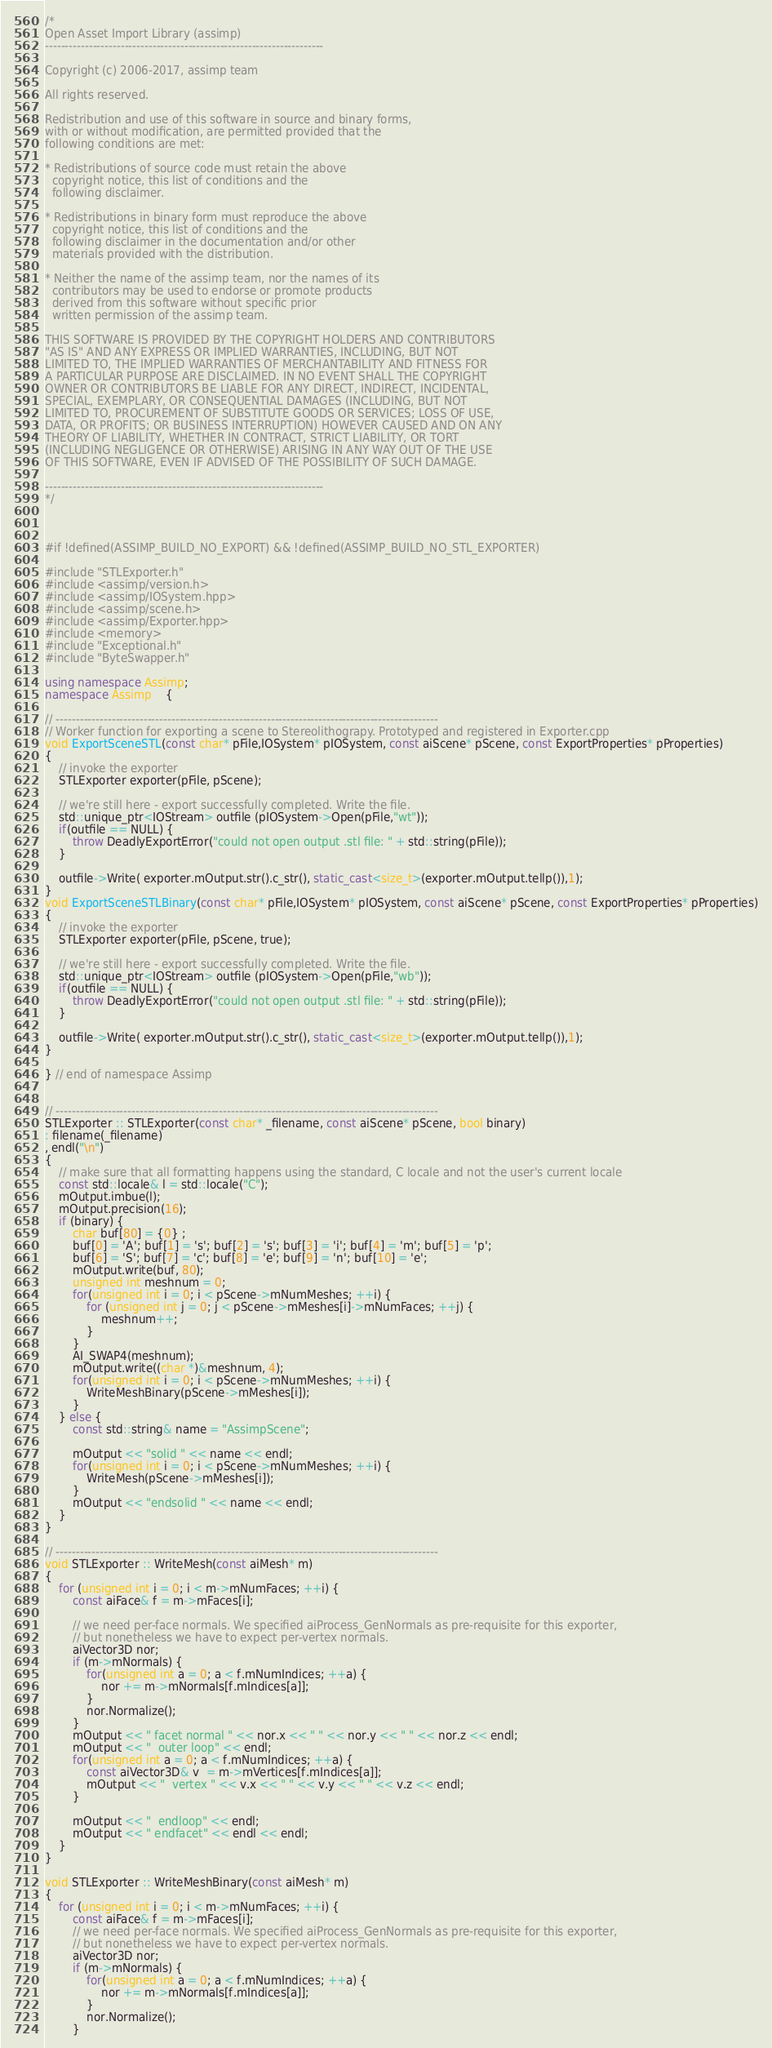<code> <loc_0><loc_0><loc_500><loc_500><_C++_>/*
Open Asset Import Library (assimp)
----------------------------------------------------------------------

Copyright (c) 2006-2017, assimp team

All rights reserved.

Redistribution and use of this software in source and binary forms,
with or without modification, are permitted provided that the
following conditions are met:

* Redistributions of source code must retain the above
  copyright notice, this list of conditions and the
  following disclaimer.

* Redistributions in binary form must reproduce the above
  copyright notice, this list of conditions and the
  following disclaimer in the documentation and/or other
  materials provided with the distribution.

* Neither the name of the assimp team, nor the names of its
  contributors may be used to endorse or promote products
  derived from this software without specific prior
  written permission of the assimp team.

THIS SOFTWARE IS PROVIDED BY THE COPYRIGHT HOLDERS AND CONTRIBUTORS
"AS IS" AND ANY EXPRESS OR IMPLIED WARRANTIES, INCLUDING, BUT NOT
LIMITED TO, THE IMPLIED WARRANTIES OF MERCHANTABILITY AND FITNESS FOR
A PARTICULAR PURPOSE ARE DISCLAIMED. IN NO EVENT SHALL THE COPYRIGHT
OWNER OR CONTRIBUTORS BE LIABLE FOR ANY DIRECT, INDIRECT, INCIDENTAL,
SPECIAL, EXEMPLARY, OR CONSEQUENTIAL DAMAGES (INCLUDING, BUT NOT
LIMITED TO, PROCUREMENT OF SUBSTITUTE GOODS OR SERVICES; LOSS OF USE,
DATA, OR PROFITS; OR BUSINESS INTERRUPTION) HOWEVER CAUSED AND ON ANY
THEORY OF LIABILITY, WHETHER IN CONTRACT, STRICT LIABILITY, OR TORT
(INCLUDING NEGLIGENCE OR OTHERWISE) ARISING IN ANY WAY OUT OF THE USE
OF THIS SOFTWARE, EVEN IF ADVISED OF THE POSSIBILITY OF SUCH DAMAGE.

----------------------------------------------------------------------
*/



#if !defined(ASSIMP_BUILD_NO_EXPORT) && !defined(ASSIMP_BUILD_NO_STL_EXPORTER)

#include "STLExporter.h"
#include <assimp/version.h>
#include <assimp/IOSystem.hpp>
#include <assimp/scene.h>
#include <assimp/Exporter.hpp>
#include <memory>
#include "Exceptional.h"
#include "ByteSwapper.h"

using namespace Assimp;
namespace Assimp    {

// ------------------------------------------------------------------------------------------------
// Worker function for exporting a scene to Stereolithograpy. Prototyped and registered in Exporter.cpp
void ExportSceneSTL(const char* pFile,IOSystem* pIOSystem, const aiScene* pScene, const ExportProperties* pProperties)
{
    // invoke the exporter
    STLExporter exporter(pFile, pScene);

    // we're still here - export successfully completed. Write the file.
    std::unique_ptr<IOStream> outfile (pIOSystem->Open(pFile,"wt"));
    if(outfile == NULL) {
        throw DeadlyExportError("could not open output .stl file: " + std::string(pFile));
    }

    outfile->Write( exporter.mOutput.str().c_str(), static_cast<size_t>(exporter.mOutput.tellp()),1);
}
void ExportSceneSTLBinary(const char* pFile,IOSystem* pIOSystem, const aiScene* pScene, const ExportProperties* pProperties)
{
    // invoke the exporter
    STLExporter exporter(pFile, pScene, true);

    // we're still here - export successfully completed. Write the file.
    std::unique_ptr<IOStream> outfile (pIOSystem->Open(pFile,"wb"));
    if(outfile == NULL) {
        throw DeadlyExportError("could not open output .stl file: " + std::string(pFile));
    }

    outfile->Write( exporter.mOutput.str().c_str(), static_cast<size_t>(exporter.mOutput.tellp()),1);
}

} // end of namespace Assimp


// ------------------------------------------------------------------------------------------------
STLExporter :: STLExporter(const char* _filename, const aiScene* pScene, bool binary)
: filename(_filename)
, endl("\n")
{
    // make sure that all formatting happens using the standard, C locale and not the user's current locale
    const std::locale& l = std::locale("C");
    mOutput.imbue(l);
    mOutput.precision(16);
    if (binary) {
        char buf[80] = {0} ;
        buf[0] = 'A'; buf[1] = 's'; buf[2] = 's'; buf[3] = 'i'; buf[4] = 'm'; buf[5] = 'p';
        buf[6] = 'S'; buf[7] = 'c'; buf[8] = 'e'; buf[9] = 'n'; buf[10] = 'e';
        mOutput.write(buf, 80);
        unsigned int meshnum = 0;
        for(unsigned int i = 0; i < pScene->mNumMeshes; ++i) {
            for (unsigned int j = 0; j < pScene->mMeshes[i]->mNumFaces; ++j) {
                meshnum++;
            }
        }
        AI_SWAP4(meshnum);
        mOutput.write((char *)&meshnum, 4);
        for(unsigned int i = 0; i < pScene->mNumMeshes; ++i) {
            WriteMeshBinary(pScene->mMeshes[i]);
        }
    } else {
        const std::string& name = "AssimpScene";

        mOutput << "solid " << name << endl;
        for(unsigned int i = 0; i < pScene->mNumMeshes; ++i) {
            WriteMesh(pScene->mMeshes[i]);
        }
        mOutput << "endsolid " << name << endl;
    }
}

// ------------------------------------------------------------------------------------------------
void STLExporter :: WriteMesh(const aiMesh* m)
{
    for (unsigned int i = 0; i < m->mNumFaces; ++i) {
        const aiFace& f = m->mFaces[i];

        // we need per-face normals. We specified aiProcess_GenNormals as pre-requisite for this exporter,
        // but nonetheless we have to expect per-vertex normals.
        aiVector3D nor;
        if (m->mNormals) {
            for(unsigned int a = 0; a < f.mNumIndices; ++a) {
                nor += m->mNormals[f.mIndices[a]];
            }
            nor.Normalize();
        }
        mOutput << " facet normal " << nor.x << " " << nor.y << " " << nor.z << endl;
        mOutput << "  outer loop" << endl;
        for(unsigned int a = 0; a < f.mNumIndices; ++a) {
            const aiVector3D& v  = m->mVertices[f.mIndices[a]];
            mOutput << "  vertex " << v.x << " " << v.y << " " << v.z << endl;
        }

        mOutput << "  endloop" << endl;
        mOutput << " endfacet" << endl << endl;
    }
}

void STLExporter :: WriteMeshBinary(const aiMesh* m)
{
    for (unsigned int i = 0; i < m->mNumFaces; ++i) {
        const aiFace& f = m->mFaces[i];
        // we need per-face normals. We specified aiProcess_GenNormals as pre-requisite for this exporter,
        // but nonetheless we have to expect per-vertex normals.
        aiVector3D nor;
        if (m->mNormals) {
            for(unsigned int a = 0; a < f.mNumIndices; ++a) {
                nor += m->mNormals[f.mIndices[a]];
            }
            nor.Normalize();
        }</code> 